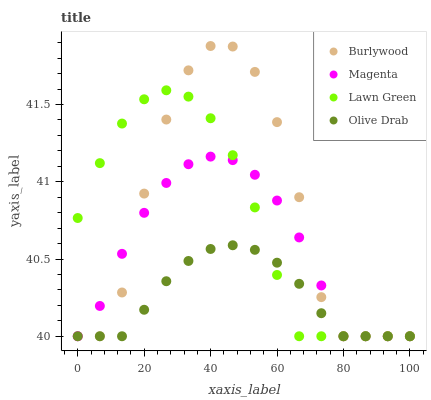Does Olive Drab have the minimum area under the curve?
Answer yes or no. Yes. Does Burlywood have the maximum area under the curve?
Answer yes or no. Yes. Does Lawn Green have the minimum area under the curve?
Answer yes or no. No. Does Lawn Green have the maximum area under the curve?
Answer yes or no. No. Is Olive Drab the smoothest?
Answer yes or no. Yes. Is Burlywood the roughest?
Answer yes or no. Yes. Is Lawn Green the smoothest?
Answer yes or no. No. Is Lawn Green the roughest?
Answer yes or no. No. Does Burlywood have the lowest value?
Answer yes or no. Yes. Does Burlywood have the highest value?
Answer yes or no. Yes. Does Lawn Green have the highest value?
Answer yes or no. No. Does Olive Drab intersect Lawn Green?
Answer yes or no. Yes. Is Olive Drab less than Lawn Green?
Answer yes or no. No. Is Olive Drab greater than Lawn Green?
Answer yes or no. No. 